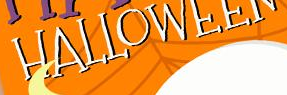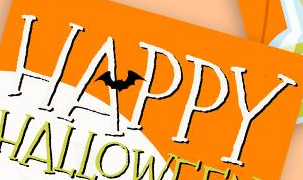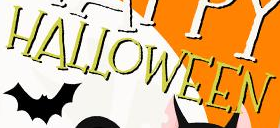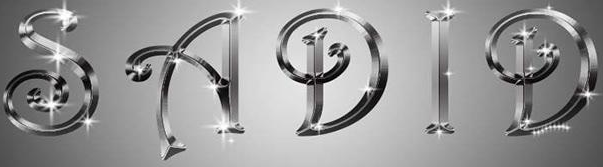What words are shown in these images in order, separated by a semicolon? HALLOWEEN; HAPPY; HALLOWEEN; SADID 